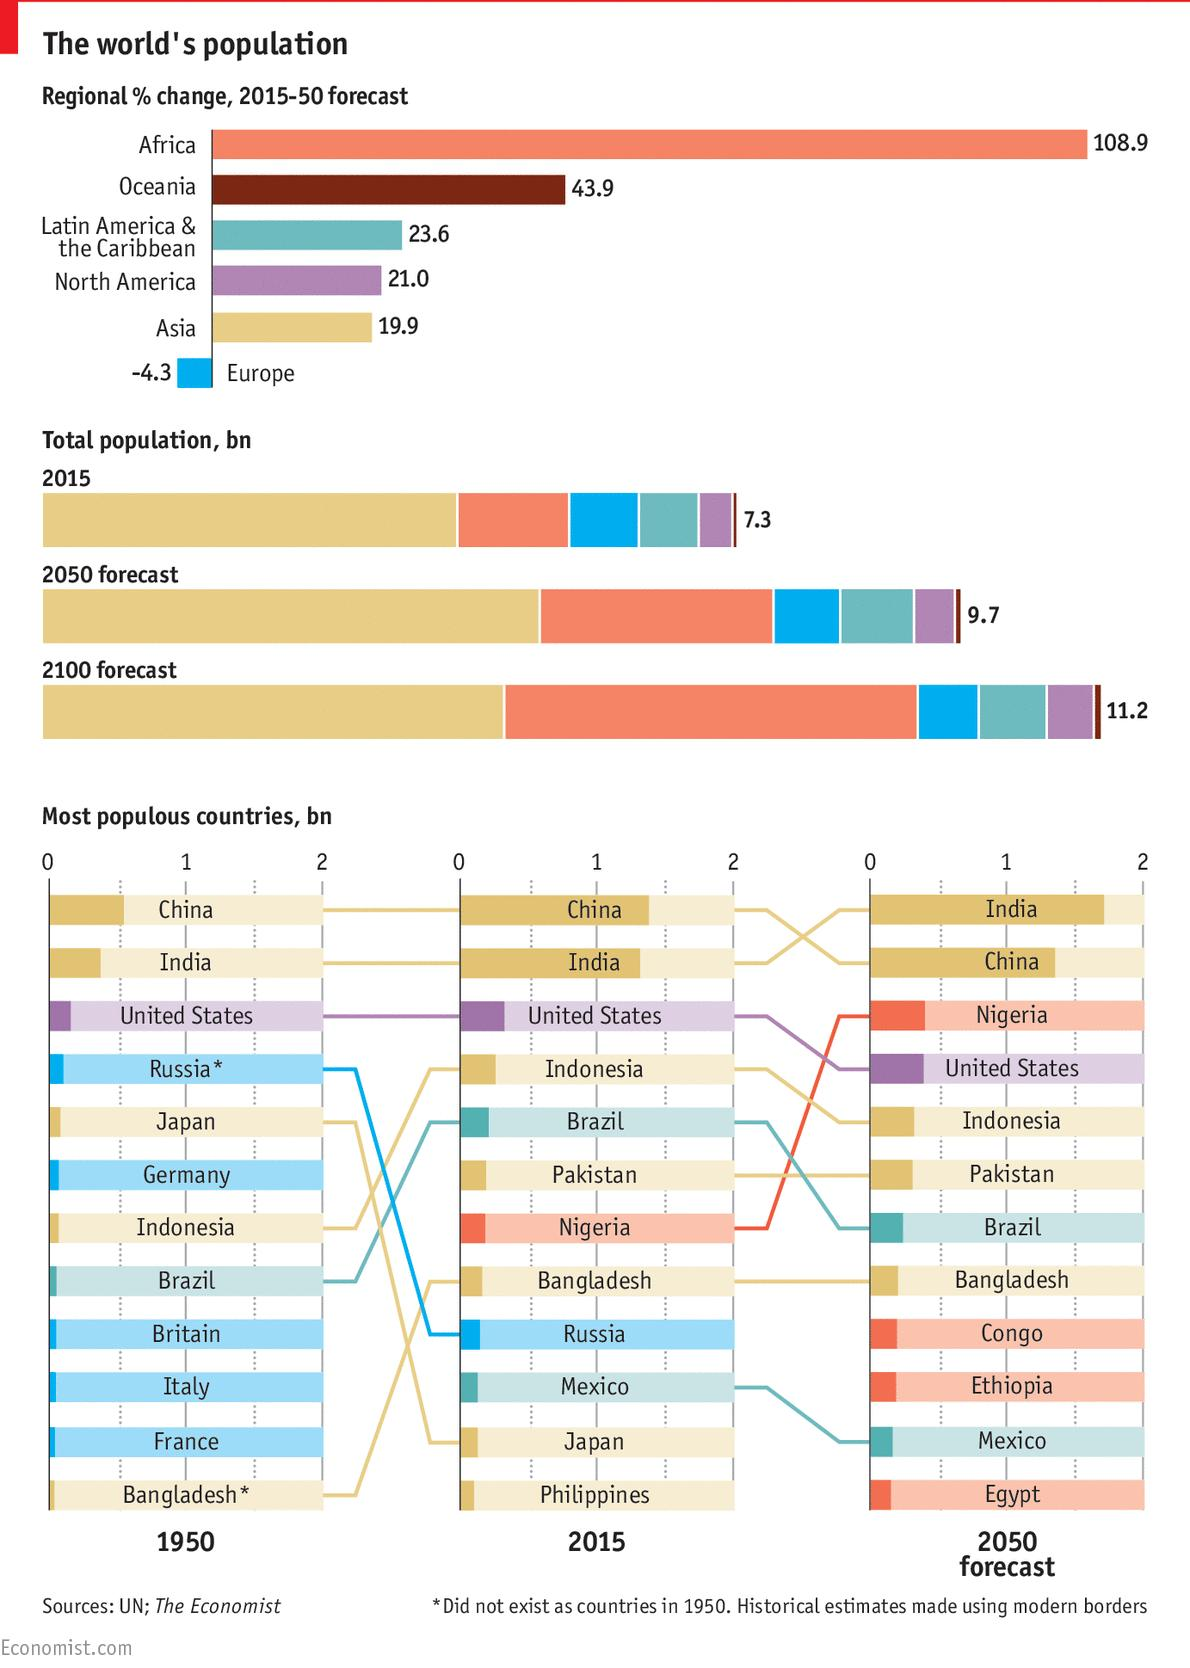Give some essential details in this illustration. It is expected that the population growth of Pakistan and Bangladesh will remain constant from 2015 to 2050. In 2015, Asia had the highest population amongst all regions. By 2050, it is projected that India will be the most populous country in the world. In 2015, the United States had the third-highest population among all countries. North America is projected to have the fourth-highest population by 2050. 